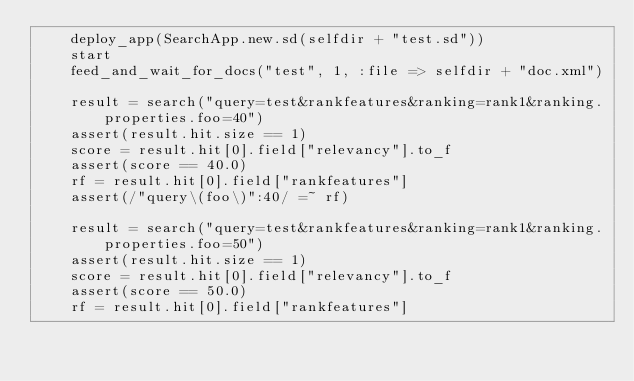<code> <loc_0><loc_0><loc_500><loc_500><_Ruby_>    deploy_app(SearchApp.new.sd(selfdir + "test.sd"))
    start
    feed_and_wait_for_docs("test", 1, :file => selfdir + "doc.xml")

    result = search("query=test&rankfeatures&ranking=rank1&ranking.properties.foo=40")
    assert(result.hit.size == 1)
    score = result.hit[0].field["relevancy"].to_f
    assert(score == 40.0)
    rf = result.hit[0].field["rankfeatures"]
    assert(/"query\(foo\)":40/ =~ rf)

    result = search("query=test&rankfeatures&ranking=rank1&ranking.properties.foo=50")
    assert(result.hit.size == 1)
    score = result.hit[0].field["relevancy"].to_f
    assert(score == 50.0)
    rf = result.hit[0].field["rankfeatures"]</code> 